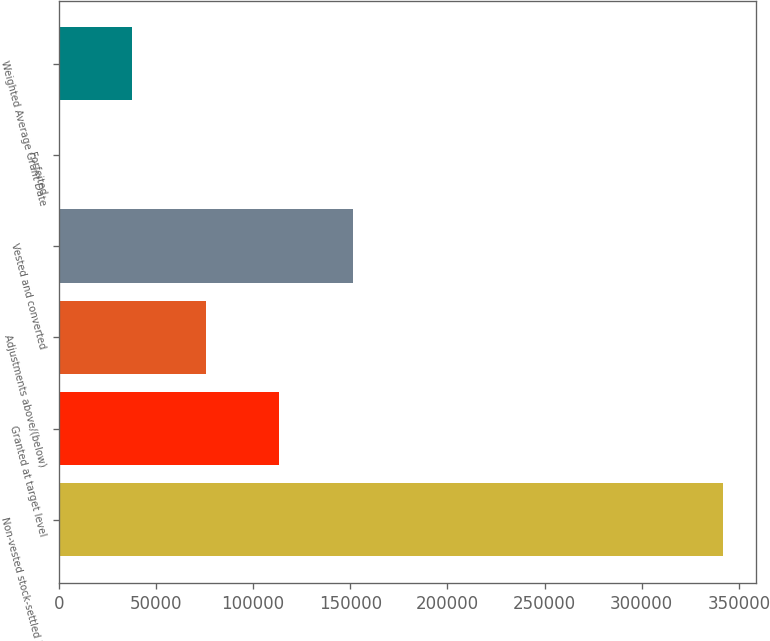Convert chart to OTSL. <chart><loc_0><loc_0><loc_500><loc_500><bar_chart><fcel>Non-vested stock-settled PSU<fcel>Granted at target level<fcel>Adjustments above/(below)<fcel>Vested and converted<fcel>Forfeited<fcel>Weighted Average Grant Date<nl><fcel>341944<fcel>113496<fcel>75700.4<fcel>151291<fcel>110<fcel>37905.2<nl></chart> 